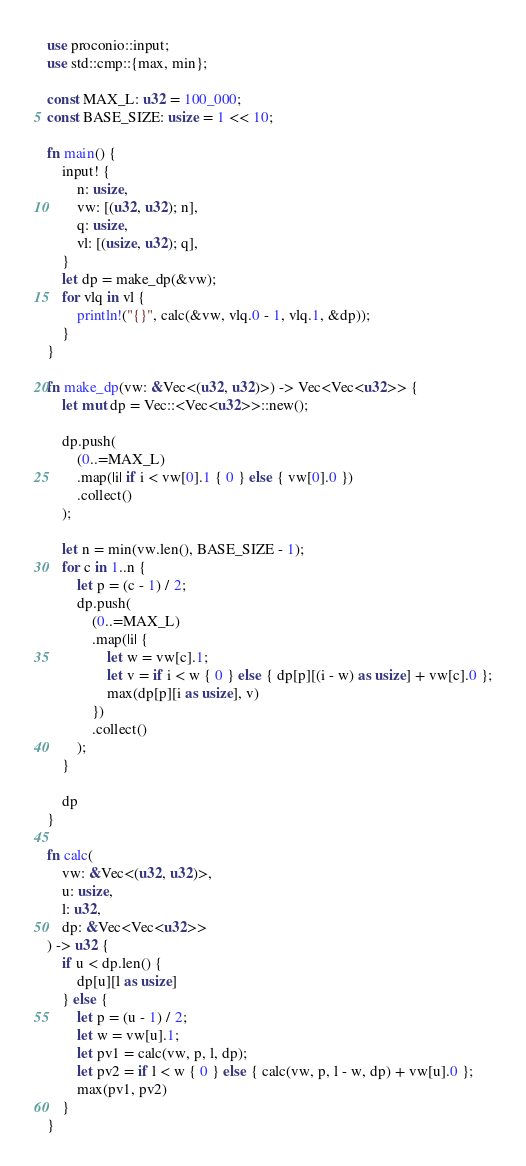<code> <loc_0><loc_0><loc_500><loc_500><_Rust_>use proconio::input;
use std::cmp::{max, min};

const MAX_L: u32 = 100_000;
const BASE_SIZE: usize = 1 << 10;

fn main() {
    input! {
        n: usize,
        vw: [(u32, u32); n],
        q: usize,
        vl: [(usize, u32); q],
    }
    let dp = make_dp(&vw);
    for vlq in vl {
        println!("{}", calc(&vw, vlq.0 - 1, vlq.1, &dp));
    }
}

fn make_dp(vw: &Vec<(u32, u32)>) -> Vec<Vec<u32>> {
    let mut dp = Vec::<Vec<u32>>::new();

    dp.push(
        (0..=MAX_L)
        .map(|i| if i < vw[0].1 { 0 } else { vw[0].0 })
        .collect()
    );

    let n = min(vw.len(), BASE_SIZE - 1);
    for c in 1..n {
        let p = (c - 1) / 2;
        dp.push(
            (0..=MAX_L)
            .map(|i| {
                let w = vw[c].1;
                let v = if i < w { 0 } else { dp[p][(i - w) as usize] + vw[c].0 };
                max(dp[p][i as usize], v)
            })
            .collect()
        );
    }

    dp
}

fn calc(
    vw: &Vec<(u32, u32)>,
    u: usize, 
    l: u32,
    dp: &Vec<Vec<u32>>
) -> u32 {
    if u < dp.len() {
        dp[u][l as usize]
    } else {
        let p = (u - 1) / 2;
        let w = vw[u].1;
        let pv1 = calc(vw, p, l, dp);
        let pv2 = if l < w { 0 } else { calc(vw, p, l - w, dp) + vw[u].0 };
        max(pv1, pv2)
    }
}
</code> 